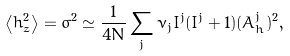<formula> <loc_0><loc_0><loc_500><loc_500>\left < h _ { z } ^ { 2 } \right > = \sigma ^ { 2 } \simeq \frac { 1 } { 4 N } \sum _ { j } \nu _ { j } I ^ { j } ( I ^ { j } + 1 ) ( A ^ { j } _ { h } ) ^ { 2 } ,</formula> 